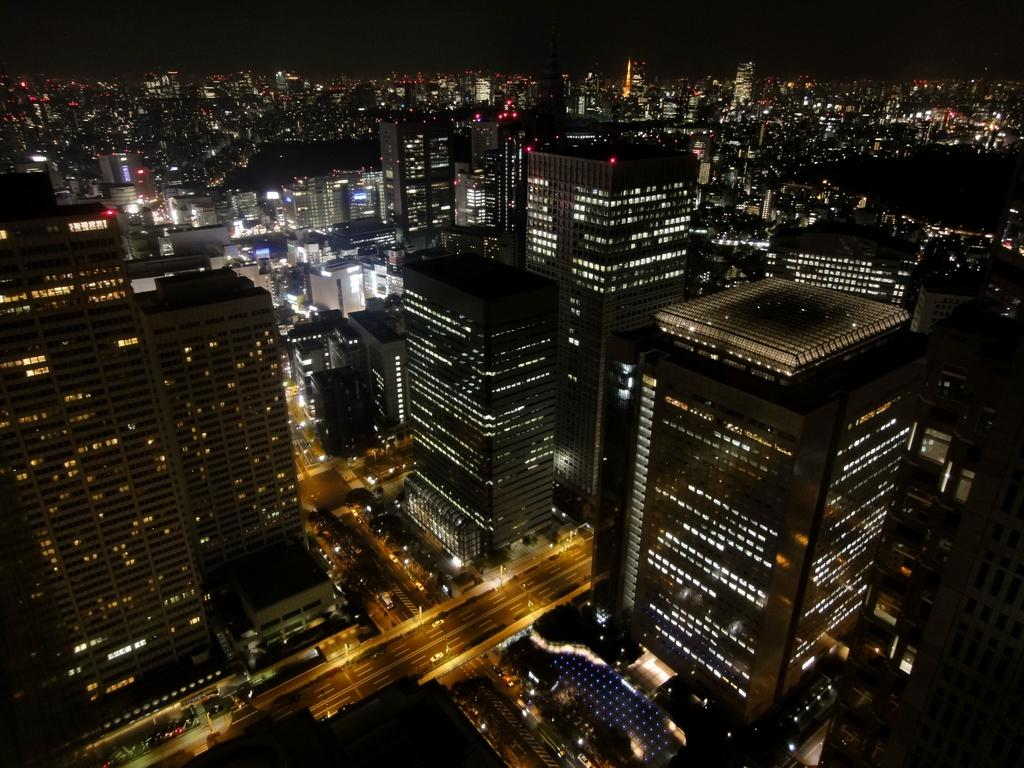What type of scene is depicted in the image? The image shows a view of the city. What can be seen on the buildings in the image? The buildings have windows and lights in the image. What is visible on the ground in the image? There is a road visible in the image. What is moving on the road in the image? Vehicles are present on the road in the image. What type of glass can be seen in the image? There is no glass present in the image; it shows a view of the city with buildings, lights, a road, and vehicles. How does the disgust in the image manifest itself? There is no indication of disgust in the image; it is a view of the city with no emotional content. 